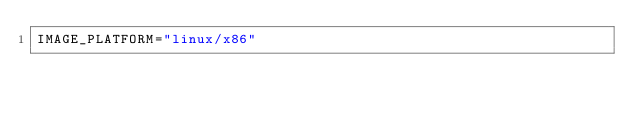<code> <loc_0><loc_0><loc_500><loc_500><_Bash_>IMAGE_PLATFORM="linux/x86"
</code> 